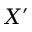Convert formula to latex. <formula><loc_0><loc_0><loc_500><loc_500>X ^ { \prime }</formula> 